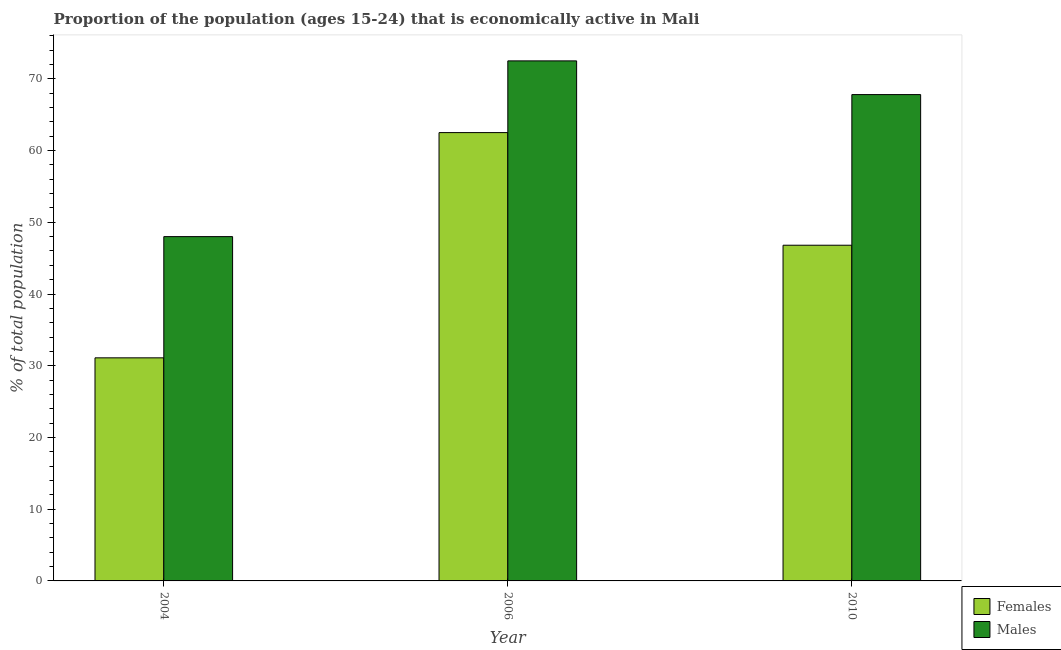Are the number of bars per tick equal to the number of legend labels?
Your response must be concise. Yes. Are the number of bars on each tick of the X-axis equal?
Give a very brief answer. Yes. How many bars are there on the 2nd tick from the left?
Your answer should be compact. 2. In how many cases, is the number of bars for a given year not equal to the number of legend labels?
Offer a very short reply. 0. What is the percentage of economically active female population in 2004?
Keep it short and to the point. 31.1. Across all years, what is the maximum percentage of economically active male population?
Provide a succinct answer. 72.5. In which year was the percentage of economically active male population maximum?
Your response must be concise. 2006. In which year was the percentage of economically active female population minimum?
Provide a succinct answer. 2004. What is the total percentage of economically active male population in the graph?
Provide a succinct answer. 188.3. What is the difference between the percentage of economically active male population in 2004 and that in 2006?
Provide a short and direct response. -24.5. What is the average percentage of economically active male population per year?
Ensure brevity in your answer.  62.77. What is the ratio of the percentage of economically active female population in 2004 to that in 2006?
Keep it short and to the point. 0.5. What is the difference between the highest and the second highest percentage of economically active male population?
Keep it short and to the point. 4.7. What does the 1st bar from the left in 2010 represents?
Ensure brevity in your answer.  Females. What does the 1st bar from the right in 2010 represents?
Your response must be concise. Males. How many bars are there?
Make the answer very short. 6. How many years are there in the graph?
Offer a terse response. 3. Does the graph contain grids?
Provide a short and direct response. No. Where does the legend appear in the graph?
Your answer should be compact. Bottom right. How are the legend labels stacked?
Provide a short and direct response. Vertical. What is the title of the graph?
Offer a terse response. Proportion of the population (ages 15-24) that is economically active in Mali. Does "Primary education" appear as one of the legend labels in the graph?
Your answer should be very brief. No. What is the label or title of the X-axis?
Ensure brevity in your answer.  Year. What is the label or title of the Y-axis?
Your answer should be compact. % of total population. What is the % of total population of Females in 2004?
Offer a terse response. 31.1. What is the % of total population of Males in 2004?
Provide a succinct answer. 48. What is the % of total population of Females in 2006?
Your answer should be very brief. 62.5. What is the % of total population in Males in 2006?
Your answer should be compact. 72.5. What is the % of total population of Females in 2010?
Your answer should be compact. 46.8. What is the % of total population in Males in 2010?
Keep it short and to the point. 67.8. Across all years, what is the maximum % of total population of Females?
Keep it short and to the point. 62.5. Across all years, what is the maximum % of total population of Males?
Make the answer very short. 72.5. Across all years, what is the minimum % of total population in Females?
Your answer should be very brief. 31.1. What is the total % of total population in Females in the graph?
Give a very brief answer. 140.4. What is the total % of total population of Males in the graph?
Provide a succinct answer. 188.3. What is the difference between the % of total population in Females in 2004 and that in 2006?
Offer a terse response. -31.4. What is the difference between the % of total population in Males in 2004 and that in 2006?
Give a very brief answer. -24.5. What is the difference between the % of total population in Females in 2004 and that in 2010?
Your response must be concise. -15.7. What is the difference between the % of total population in Males in 2004 and that in 2010?
Your response must be concise. -19.8. What is the difference between the % of total population in Males in 2006 and that in 2010?
Give a very brief answer. 4.7. What is the difference between the % of total population of Females in 2004 and the % of total population of Males in 2006?
Give a very brief answer. -41.4. What is the difference between the % of total population in Females in 2004 and the % of total population in Males in 2010?
Your answer should be very brief. -36.7. What is the difference between the % of total population of Females in 2006 and the % of total population of Males in 2010?
Ensure brevity in your answer.  -5.3. What is the average % of total population in Females per year?
Provide a short and direct response. 46.8. What is the average % of total population in Males per year?
Provide a short and direct response. 62.77. In the year 2004, what is the difference between the % of total population of Females and % of total population of Males?
Offer a terse response. -16.9. In the year 2006, what is the difference between the % of total population in Females and % of total population in Males?
Your response must be concise. -10. What is the ratio of the % of total population of Females in 2004 to that in 2006?
Ensure brevity in your answer.  0.5. What is the ratio of the % of total population in Males in 2004 to that in 2006?
Offer a very short reply. 0.66. What is the ratio of the % of total population in Females in 2004 to that in 2010?
Offer a terse response. 0.66. What is the ratio of the % of total population of Males in 2004 to that in 2010?
Your answer should be very brief. 0.71. What is the ratio of the % of total population in Females in 2006 to that in 2010?
Ensure brevity in your answer.  1.34. What is the ratio of the % of total population in Males in 2006 to that in 2010?
Your response must be concise. 1.07. What is the difference between the highest and the second highest % of total population of Females?
Provide a succinct answer. 15.7. What is the difference between the highest and the lowest % of total population in Females?
Offer a very short reply. 31.4. What is the difference between the highest and the lowest % of total population in Males?
Ensure brevity in your answer.  24.5. 